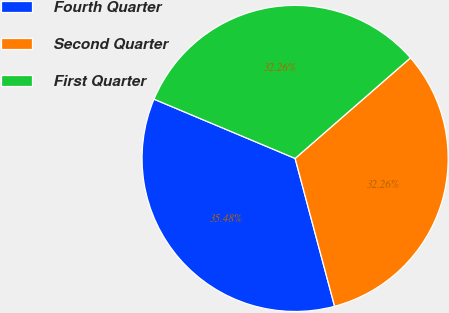Convert chart to OTSL. <chart><loc_0><loc_0><loc_500><loc_500><pie_chart><fcel>Fourth Quarter<fcel>Second Quarter<fcel>First Quarter<nl><fcel>35.48%<fcel>32.26%<fcel>32.26%<nl></chart> 